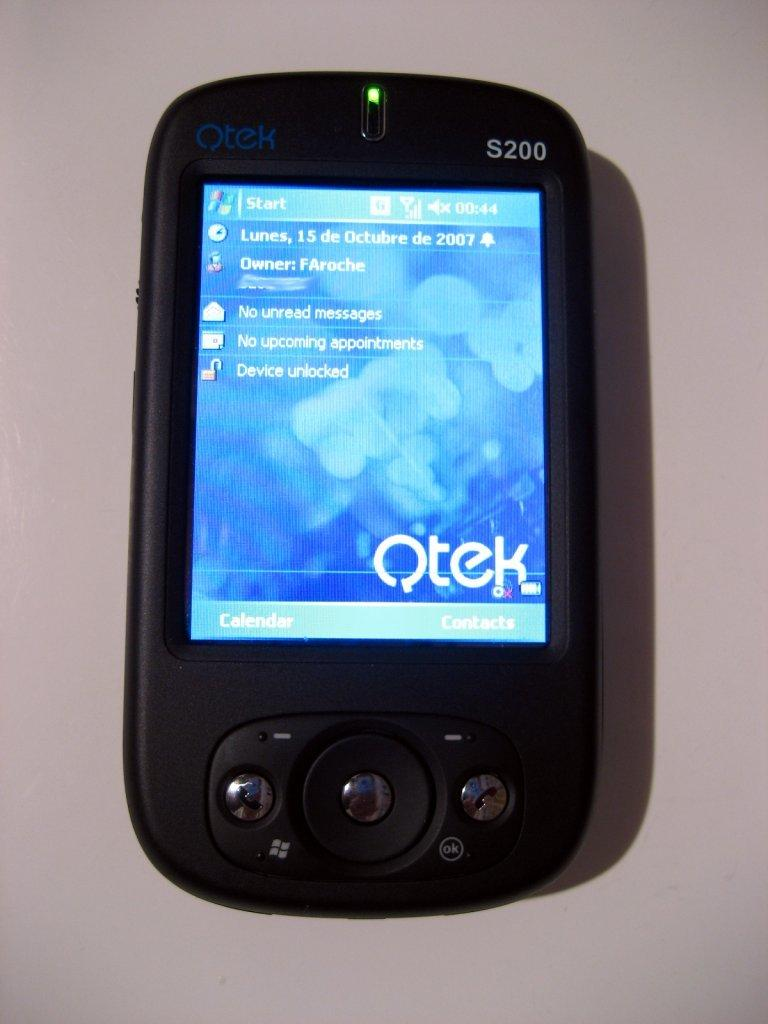<image>
Write a terse but informative summary of the picture. An Otek S200 phone showing a home screen 